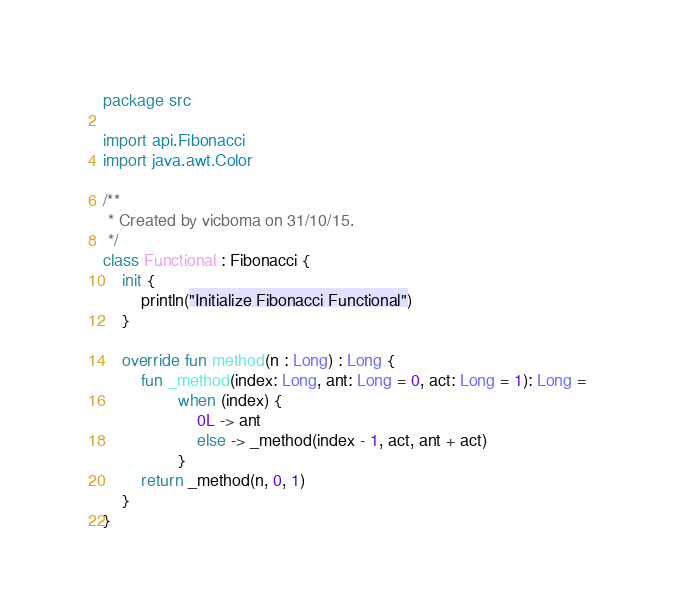<code> <loc_0><loc_0><loc_500><loc_500><_Kotlin_>package src

import api.Fibonacci
import java.awt.Color

/**
 * Created by vicboma on 31/10/15.
 */
class Functional : Fibonacci {
    init {
        println("Initialize Fibonacci Functional")
    }

    override fun method(n : Long) : Long {
        fun _method(index: Long, ant: Long = 0, act: Long = 1): Long =
                when (index) {
                    0L -> ant
                    else -> _method(index - 1, act, ant + act)
                }
        return _method(n, 0, 1)
    }
}</code> 